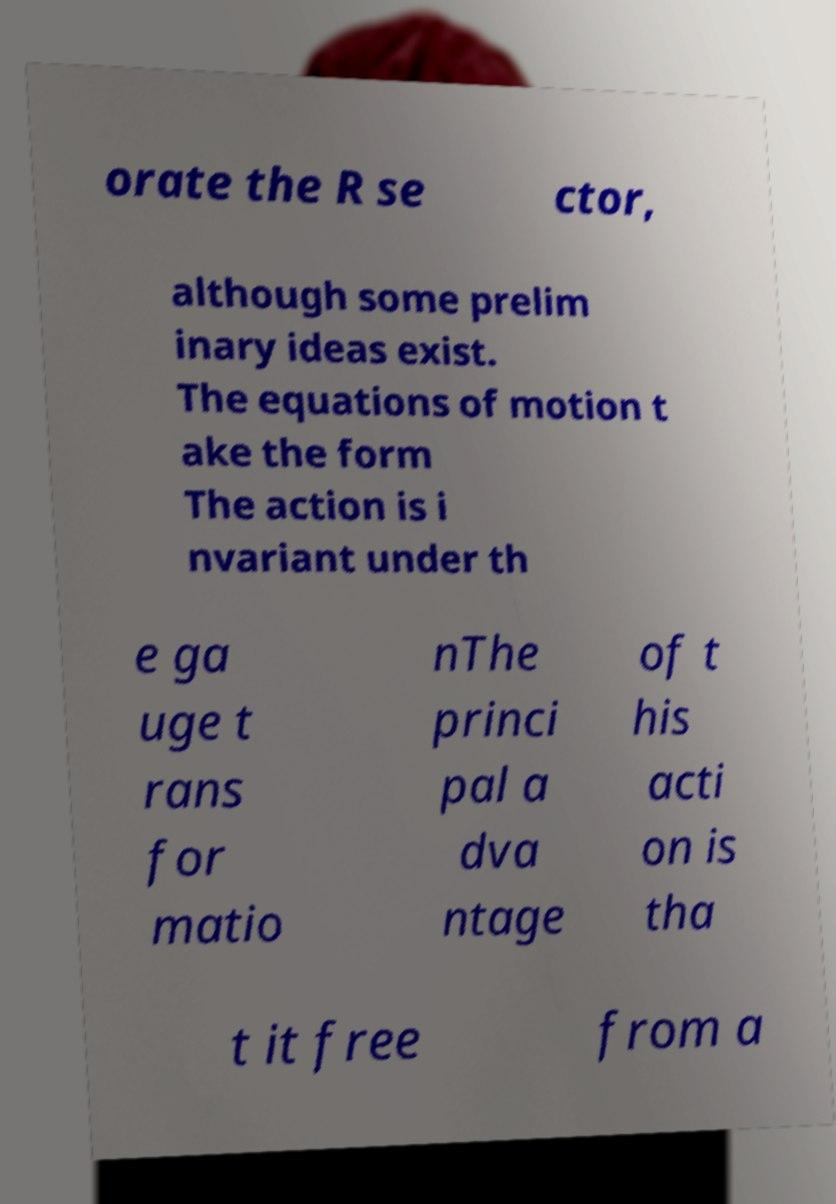Please read and relay the text visible in this image. What does it say? orate the R se ctor, although some prelim inary ideas exist. The equations of motion t ake the form The action is i nvariant under th e ga uge t rans for matio nThe princi pal a dva ntage of t his acti on is tha t it free from a 